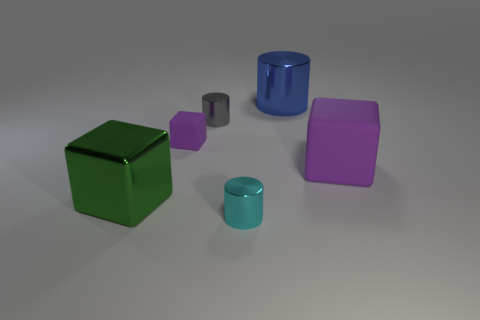Are there the same number of purple blocks that are behind the big purple thing and big blue rubber balls?
Your response must be concise. No. What number of objects are small shiny cylinders behind the cyan metallic cylinder or rubber cylinders?
Give a very brief answer. 1. There is a small metal thing in front of the big purple block; does it have the same color as the large shiny cylinder?
Offer a terse response. No. There is a object that is in front of the metal block; how big is it?
Offer a terse response. Small. The purple matte thing that is on the right side of the purple thing left of the cyan thing is what shape?
Provide a succinct answer. Cube. There is another small metal thing that is the same shape as the small cyan shiny thing; what color is it?
Your answer should be very brief. Gray. Do the purple cube that is left of the gray shiny object and the large shiny block have the same size?
Provide a succinct answer. No. The object that is the same color as the small rubber cube is what shape?
Make the answer very short. Cube. How many other objects are made of the same material as the gray thing?
Give a very brief answer. 3. There is a thing that is in front of the large object that is on the left side of the big metallic cylinder behind the small purple rubber object; what is it made of?
Provide a succinct answer. Metal. 